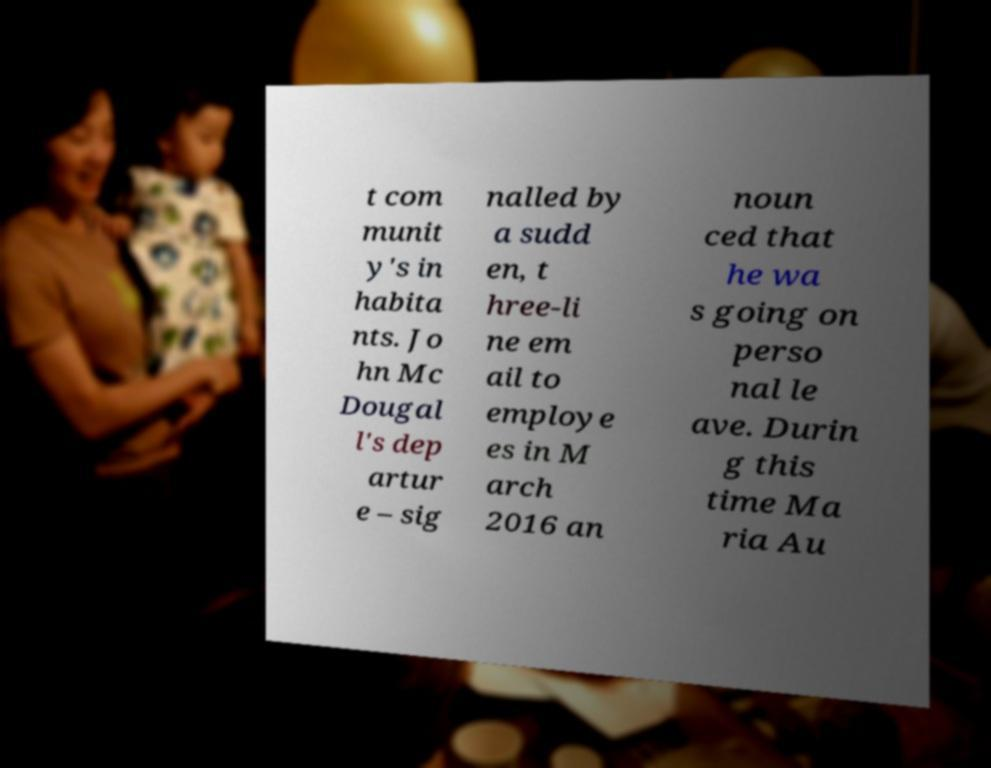Can you read and provide the text displayed in the image?This photo seems to have some interesting text. Can you extract and type it out for me? t com munit y's in habita nts. Jo hn Mc Dougal l's dep artur e – sig nalled by a sudd en, t hree-li ne em ail to employe es in M arch 2016 an noun ced that he wa s going on perso nal le ave. Durin g this time Ma ria Au 